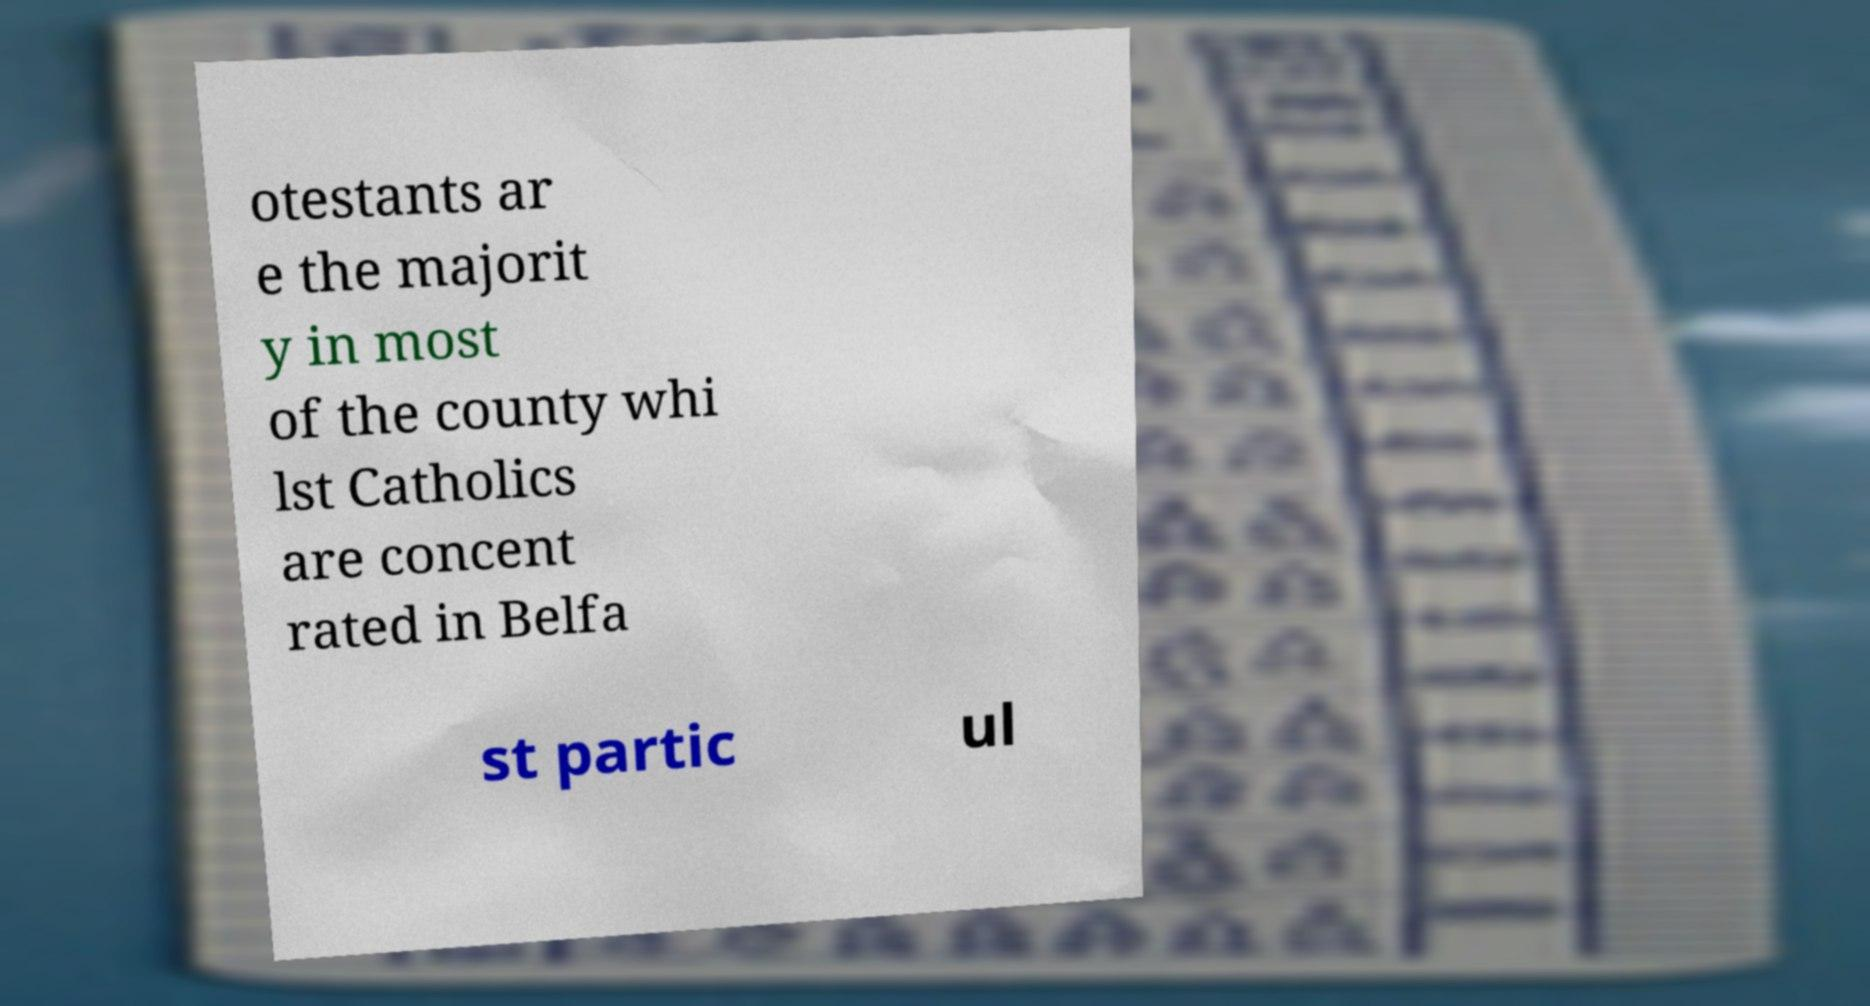Please identify and transcribe the text found in this image. otestants ar e the majorit y in most of the county whi lst Catholics are concent rated in Belfa st partic ul 